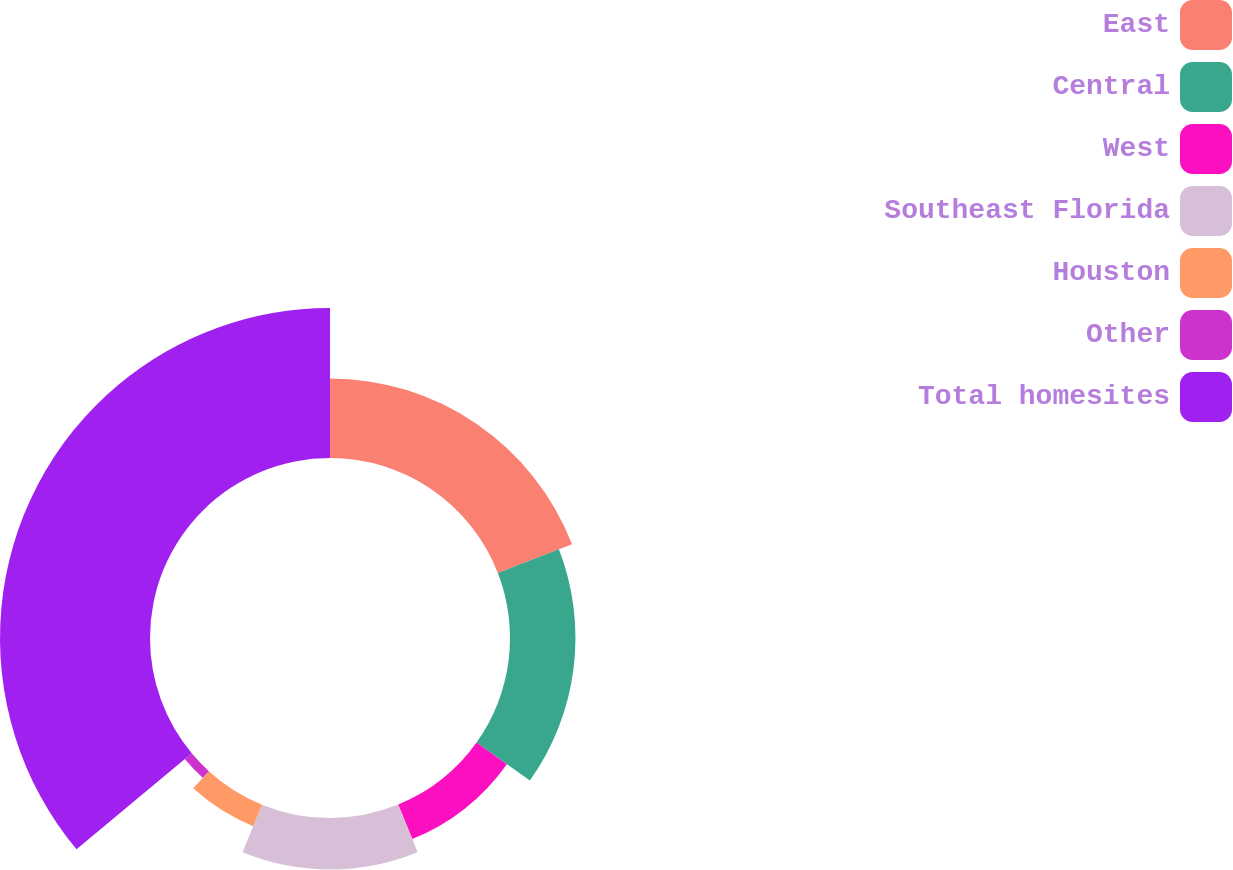<chart> <loc_0><loc_0><loc_500><loc_500><pie_chart><fcel>East<fcel>Central<fcel>West<fcel>Southeast Florida<fcel>Houston<fcel>Other<fcel>Total homesites<nl><fcel>19.12%<fcel>15.74%<fcel>8.96%<fcel>12.35%<fcel>5.58%<fcel>2.19%<fcel>36.06%<nl></chart> 